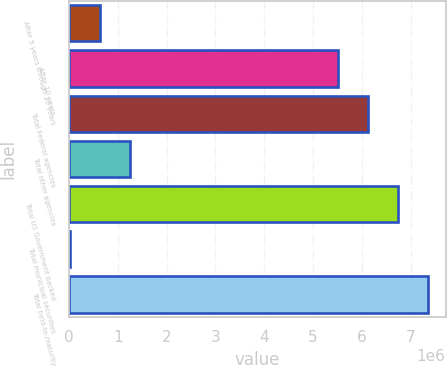Convert chart. <chart><loc_0><loc_0><loc_500><loc_500><bar_chart><fcel>After 5 years through 10 years<fcel>After 10 years<fcel>Total Federal agencies<fcel>Total other agencies<fcel>Total US Government backed<fcel>Total municipal securities<fcel>Total held-to-maturity<nl><fcel>622292<fcel>5.50659e+06<fcel>6.12185e+06<fcel>1.23755e+06<fcel>6.7371e+06<fcel>7037<fcel>7.35236e+06<nl></chart> 